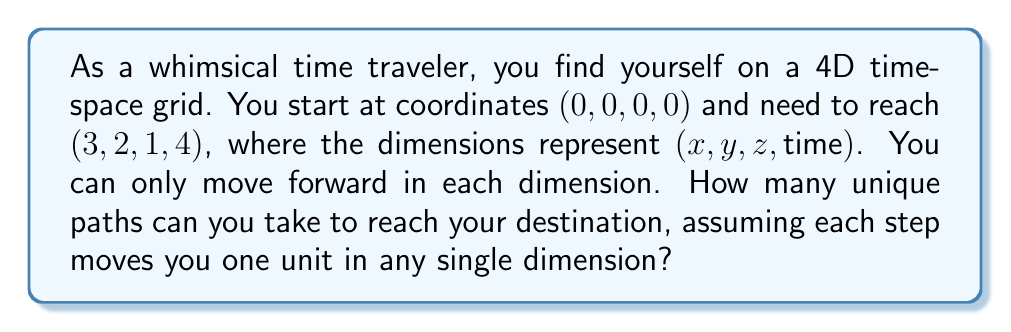Give your solution to this math problem. Let's approach this step-by-step:

1) First, we need to recognize that this problem is equivalent to finding the number of ways to arrange the moves in different dimensions. We need to make:
   - 3 moves in the x direction
   - 2 moves in the y direction
   - 1 move in the z direction
   - 4 moves in the time dimension

2) The total number of moves is $3 + 2 + 1 + 4 = 10$.

3) This problem can be solved using the concept of combinations with repetition, specifically the multinomial coefficient.

4) The formula for the multinomial coefficient is:

   $$\frac{n!}{n_1! n_2! \ldots n_k!}$$

   where $n$ is the total number of items, and $n_1, n_2, \ldots, n_k$ are the numbers of each type of item.

5) In our case:
   $n = 10$ (total moves)
   $n_1 = 3$ (x moves)
   $n_2 = 2$ (y moves)
   $n_3 = 1$ (z move)
   $n_4 = 4$ (time moves)

6) Plugging these into the formula:

   $$\frac{10!}{3! 2! 1! 4!}$$

7) Calculating this:
   
   $$\frac{10 * 9 * 8 * 7 * 6 * 5!}{(3 * 2 * 1) * (2 * 1) * (1) * (4 * 3 * 2 * 1)}$$

8) Simplifying:
   
   $$\frac{10 * 9 * 8 * 7 * 6}{6 * 2 * 4 * 3 * 2} = 12600$$

Therefore, there are 12,600 unique paths to travel between these two points on the 4D time-space grid.
Answer: 12,600 unique paths 